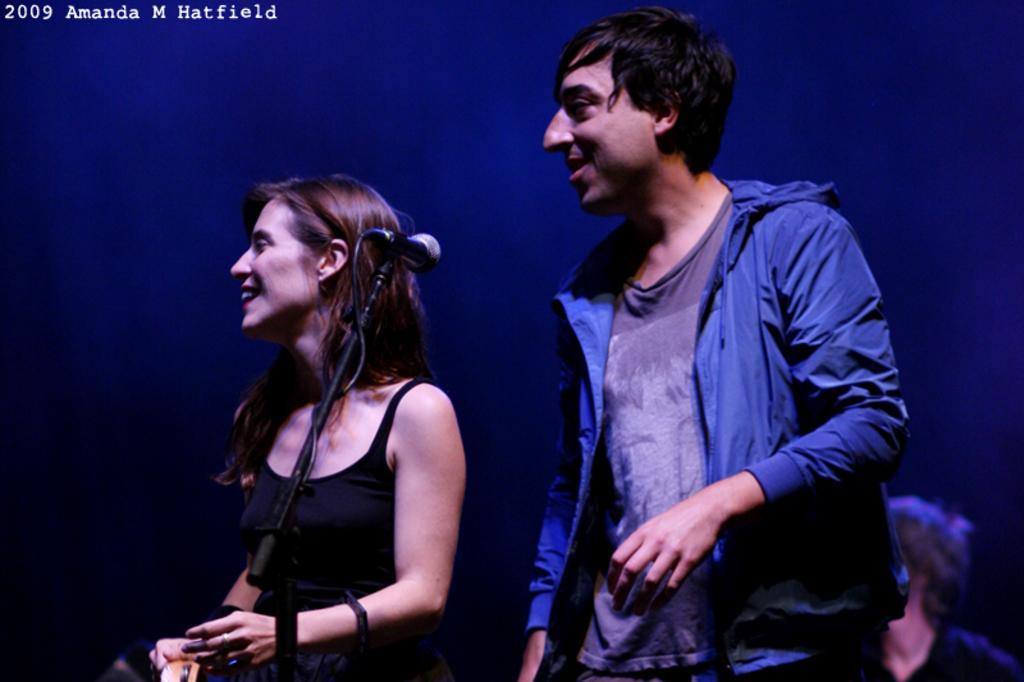Can you describe this image briefly? On the left side, there is a woman in a black color dress, smiling and standing. Beside her, there is a mic attached to a stand. On the top left, there is a watermark. In the background, there is a person. And the background is blue in color. 